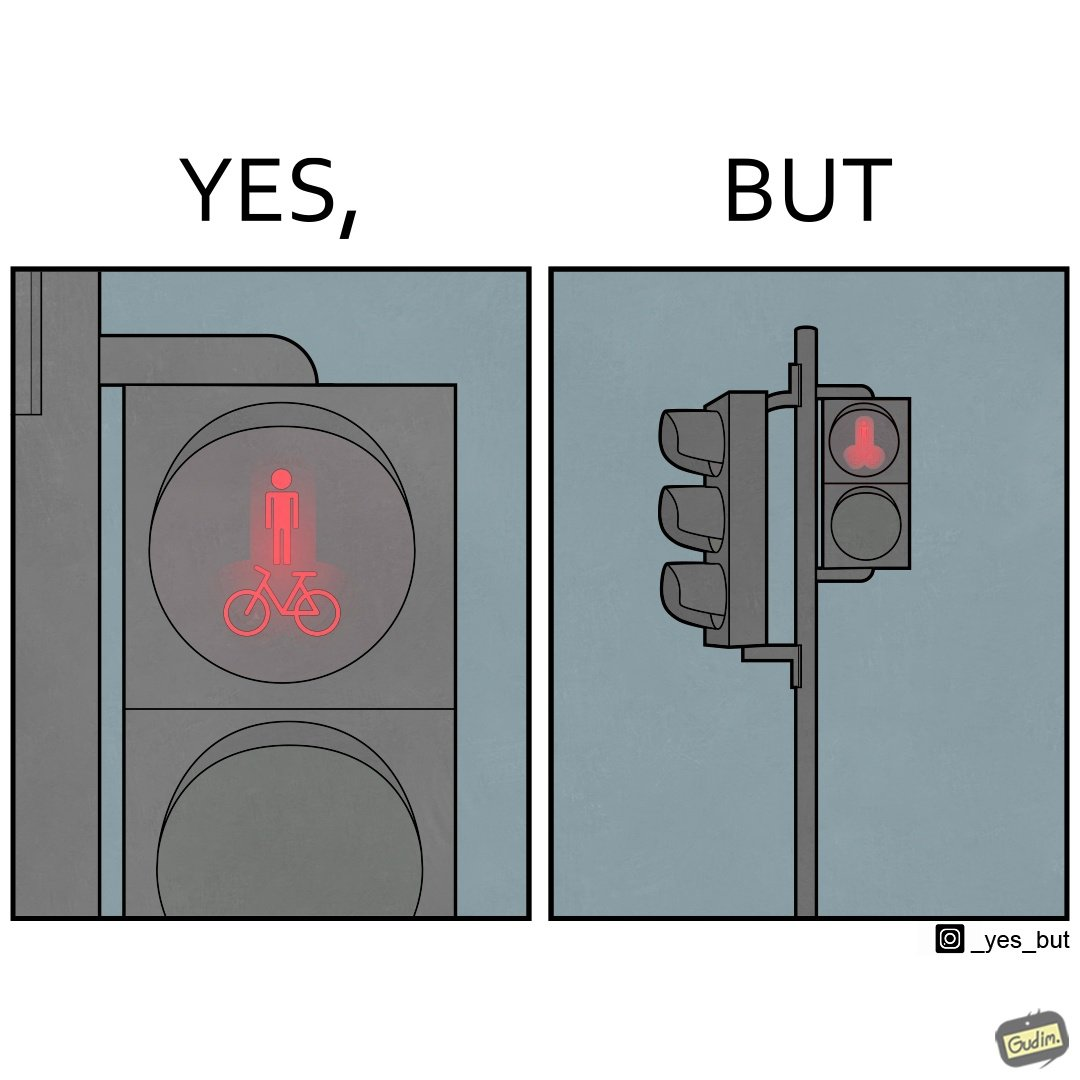Explain the humor or irony in this image. This image is funny because images of very regular things - a stick figure and a bicycle, get converted into  looking phallic from a distance. 